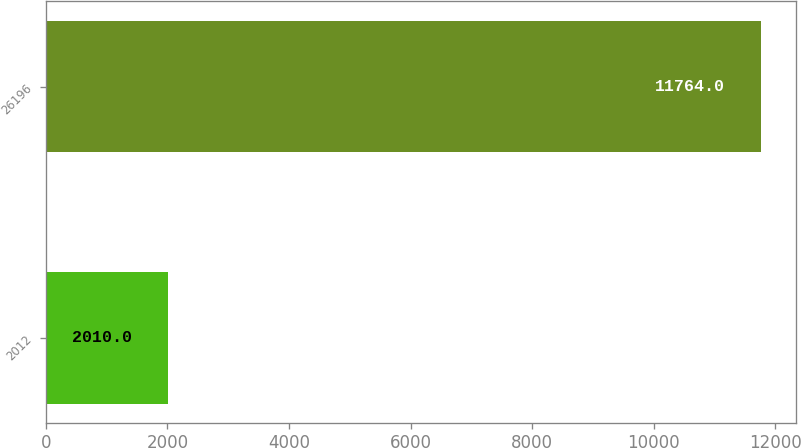Convert chart. <chart><loc_0><loc_0><loc_500><loc_500><bar_chart><fcel>2012<fcel>26196<nl><fcel>2010<fcel>11764<nl></chart> 